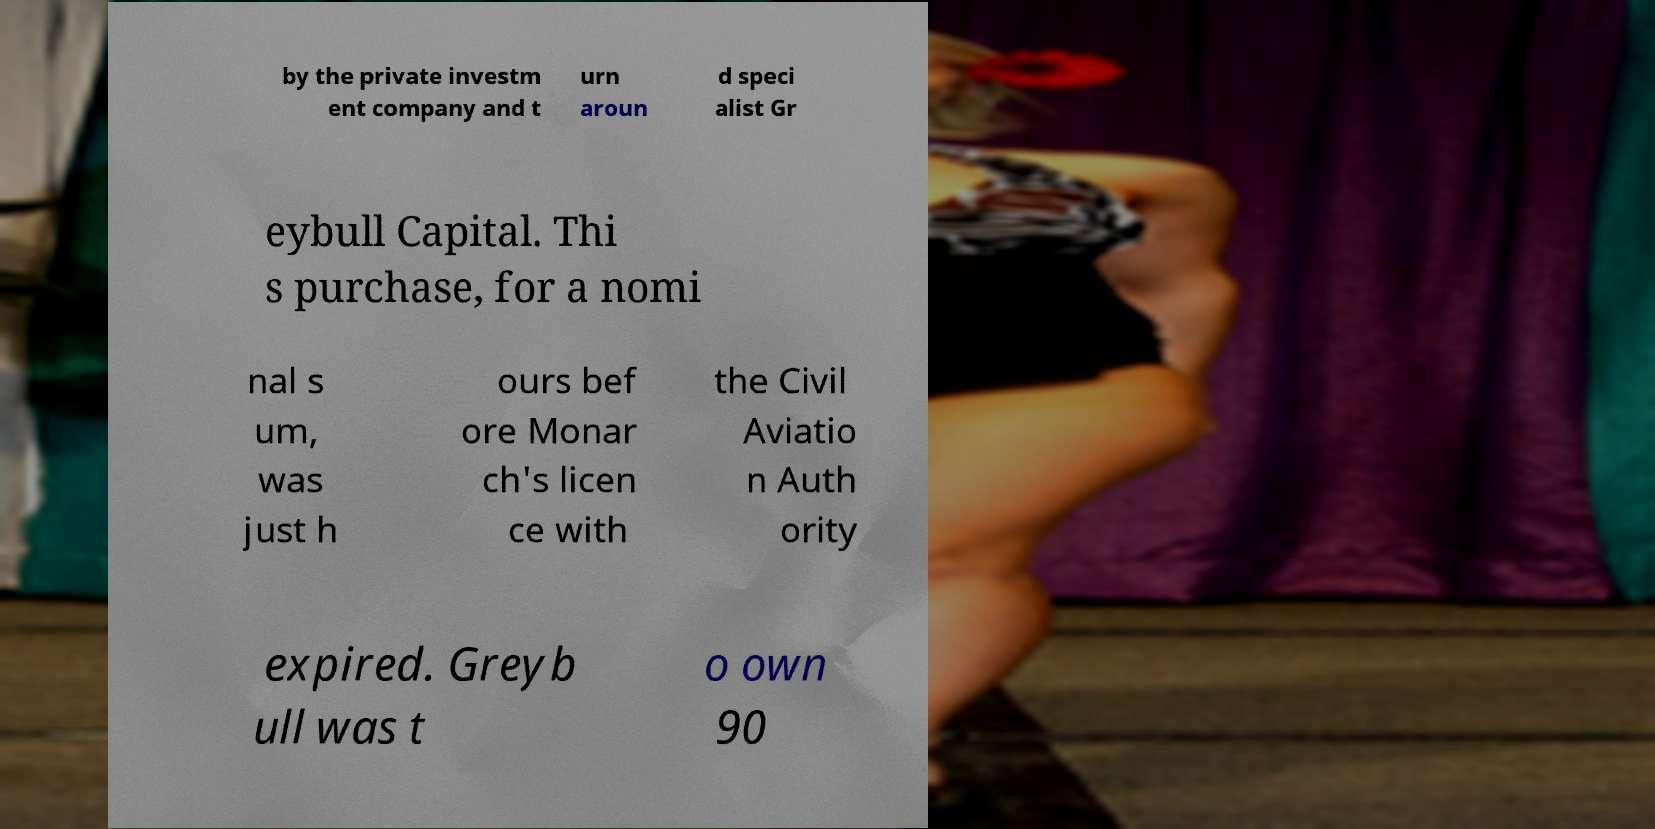Can you read and provide the text displayed in the image?This photo seems to have some interesting text. Can you extract and type it out for me? by the private investm ent company and t urn aroun d speci alist Gr eybull Capital. Thi s purchase, for a nomi nal s um, was just h ours bef ore Monar ch's licen ce with the Civil Aviatio n Auth ority expired. Greyb ull was t o own 90 